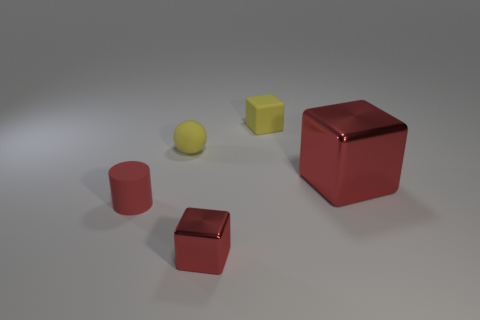How does the lighting affect the colors of the objects in the image? The lighting in the image casts soft shadows and gives a slight shine to the objects, particularly noticeable on the larger, reflective cube. This subtle lighting condition helps maintain the integrity of the objects' colors while providing a sense of depth and texture. 